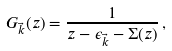Convert formula to latex. <formula><loc_0><loc_0><loc_500><loc_500>G _ { \vec { k } } ( z ) = \frac { 1 } { z - \epsilon _ { \vec { k } } - \Sigma ( z ) } \, ,</formula> 